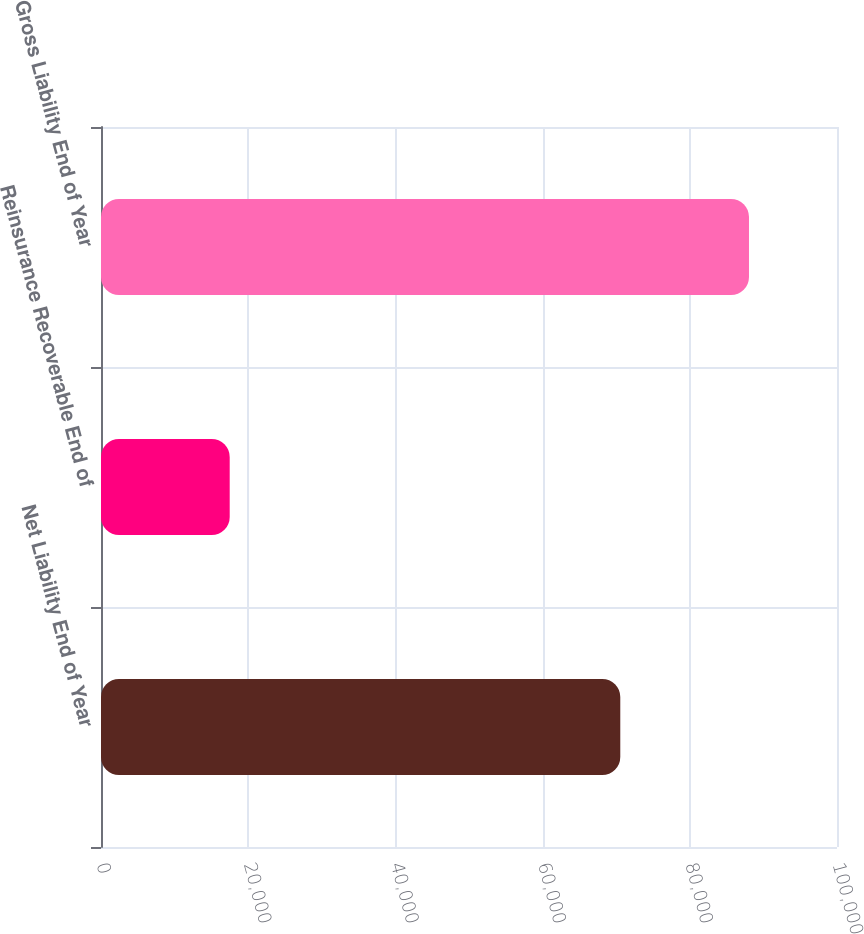<chart> <loc_0><loc_0><loc_500><loc_500><bar_chart><fcel>Net Liability End of Year<fcel>Reinsurance Recoverable End of<fcel>Gross Liability End of Year<nl><fcel>70554<fcel>17487<fcel>88041<nl></chart> 